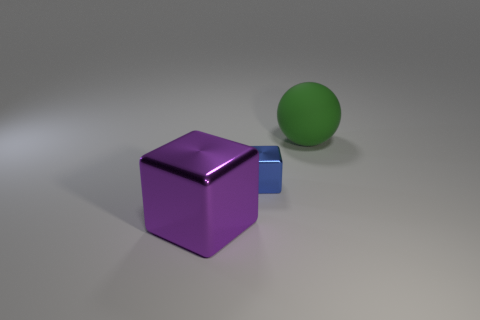Does the matte object have the same color as the tiny shiny cube?
Your response must be concise. No. What number of other objects are there of the same shape as the large matte object?
Make the answer very short. 0. Is the color of the large thing that is on the right side of the large metallic cube the same as the big metal object?
Keep it short and to the point. No. Is there another big block of the same color as the large metallic cube?
Provide a succinct answer. No. There is a big metallic block; how many purple objects are in front of it?
Provide a short and direct response. 0. How many other objects are there of the same size as the purple cube?
Give a very brief answer. 1. Does the big thing to the right of the purple object have the same material as the thing to the left of the small blue block?
Provide a succinct answer. No. There is a matte object that is the same size as the purple shiny thing; what color is it?
Offer a terse response. Green. Are there any other things of the same color as the large sphere?
Make the answer very short. No. What is the size of the block that is to the right of the block that is in front of the metal block behind the large cube?
Your answer should be very brief. Small. 